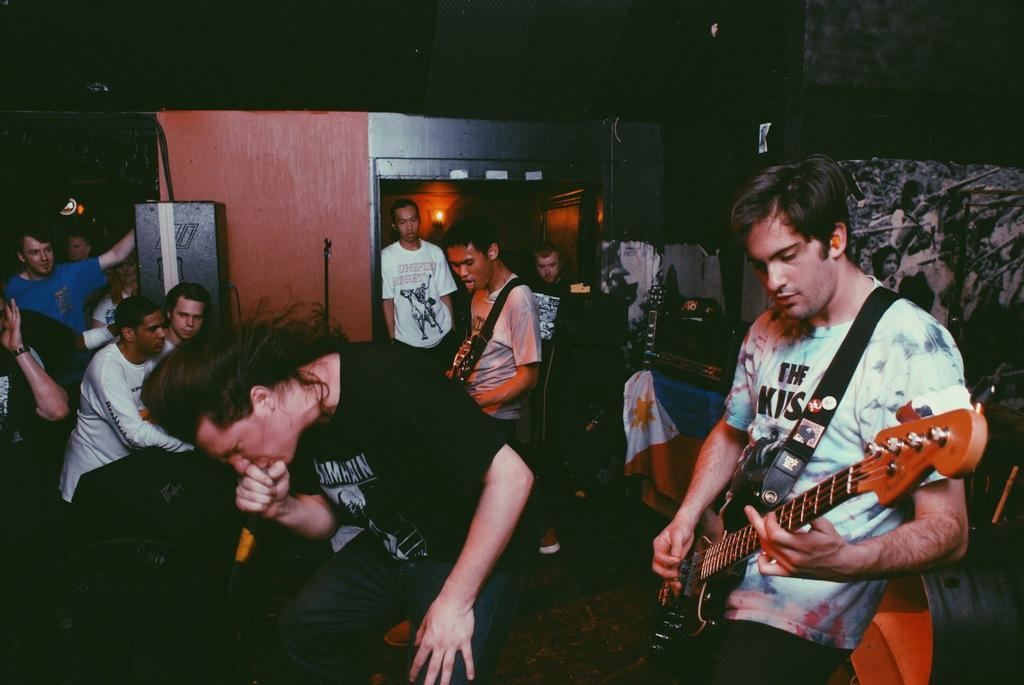Describe this image in one or two sentences. In this picture we can see two men playing guitars on the platform. We can see this man holding a mike in his hand and singing. We can see all the persons starting to these performers. This is a light. 